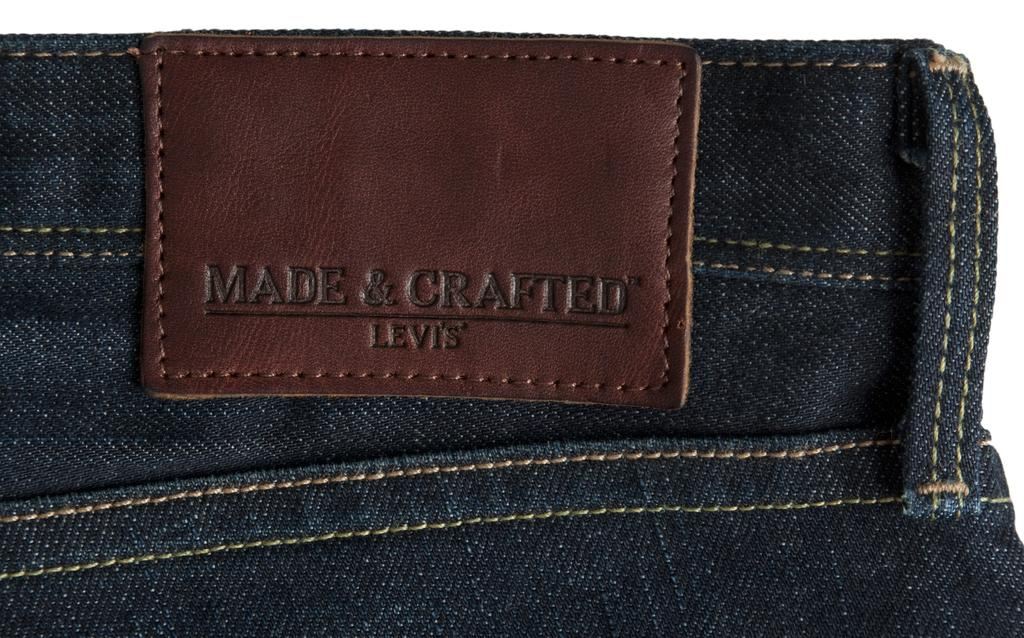What type of clothing item is in the image? There is a pair of jeans in the image. What feature is present on the jeans? The jeans have a tag. What information can be found on the tag? There is text on the tag. What type of kite is being cut with the scissors in the image? There is no kite or scissors present in the image; it only features a pair of jeans with a tag. What type of stem can be seen growing from the jeans in the image? There is: There is no stem present in the image; it only features a pair of jeans with a tag. 